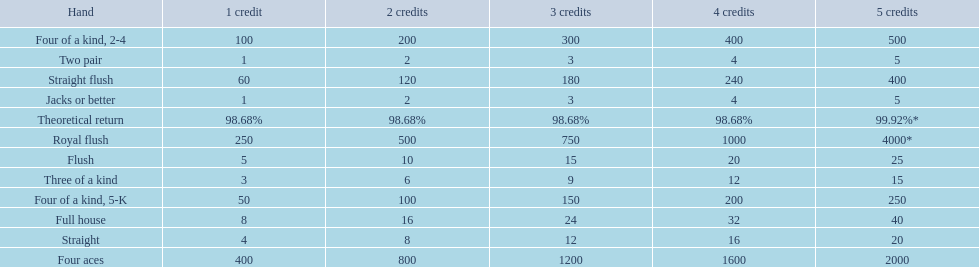Which hand is lower than straight flush? Four aces. Which hand is lower than four aces? Four of a kind, 2-4. Which hand is higher out of straight and flush? Flush. 